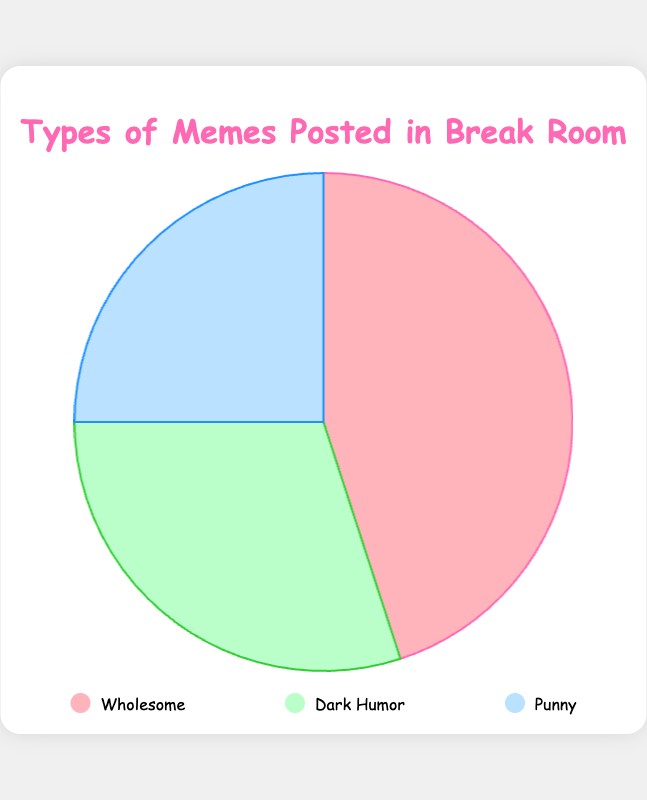What is the most common type of meme posted in the break room? Referring to the pie chart, the largest segment corresponds to Wholesome memes.
Answer: Wholesome Which type of meme is the least common in the break room? According to the pie chart, the smallest segment corresponds to Punny memes.
Answer: Punny What percentage of memes are either Dark Humor or Punny? The percentages for Dark Humor and Punny are 30% and 25%, respectively. Adding them together, 30 + 25 = 55%.
Answer: 55% How much more common are Wholesome memes compared to Dark Humor memes? Wholesome memes are 45% while Dark Humor memes are 30%. The difference is 45 - 30 = 15%.
Answer: 15% If the total number of memes is 200, how many of them are Wholesome? Wholesome memes make up 45% of the total. To find the number of Wholesome memes, calculate 45% of 200, which is 200 * 0.45 = 90.
Answer: 90 Which two types of memes together account for more than half of all memes posted? Wholesome memes account for 45% and Dark Humor memes account for 30%. Adding these, 45 + 30 = 75%, which is more than half.
Answer: Wholesome and Dark Humor How do the sizes of segments visually compare between Dark Humor and Punny memes? The segment for Dark Humor is visually larger than the segment for Punny memes.
Answer: Dark Humor is larger What is the combined percentage of memes that are not Wholesome? The percentage of Wholesome memes is 45%. Therefore, the percentage of non-Wholesome memes is 100% - 45% = 55%.
Answer: 55% Is the percentage difference between Dark Humor and Punny memes larger or smaller than 10%? The difference between Dark Humor (30%) and Punny (25%) is 30 - 25 = 5%, which is smaller than 10%.
Answer: Smaller If we combine Wholesome and Punny memes, what fraction of the total do they represent? Wholesome memes are 45% and Punny memes are 25%. Combined, they represent 45 + 25 = 70% of the total, which is 70/100 or 7/10.
Answer: 7/10 